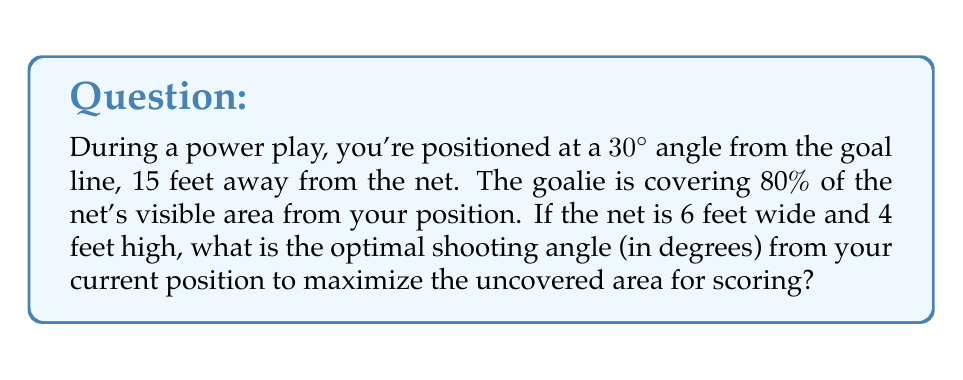Can you solve this math problem? Let's approach this step-by-step:

1) First, we need to calculate the visible area of the net from your position. The net's dimensions are 6 feet wide and 4 feet high, but due to your angle, the visible width will be less.

2) The visible width can be calculated using trigonometry:
   $$\text{Visible Width} = 6 \cdot \cos(30°) = 6 \cdot \frac{\sqrt{3}}{2} = 3\sqrt{3} \approx 5.2 \text{ feet}$$

3) The visible area of the net is thus:
   $$\text{Visible Area} = 5.2 \cdot 4 = 20.8 \text{ sq feet}$$

4) The goalie is covering 80% of this area, leaving 20% uncovered:
   $$\text{Uncovered Area} = 20.8 \cdot 0.2 = 4.16 \text{ sq feet}$$

5) To maximize the uncovered area for scoring, we need to aim for the center of this uncovered area. 

6) The uncovered area can be approximated as a rectangle. If we assume it's evenly distributed around the edges of the net, its center would be at the same spot as the center of the entire visible net area.

7) To find the optimal angle, we need to calculate the angle to the center of the visible net from your position:

   [asy]
   import geometry;
   
   pair A = (0,0);  // Your position
   pair B = (15*cos(30*pi/180), 15*sin(30*pi/180));  // Net center
   
   draw(A--B);
   draw((0,0)--(20,0), arrow=Arrow(TeXHead));
   draw((0,0)--(0,10), arrow=Arrow(TeXHead));
   
   label("You", A, SW);
   label("Net Center", B, NE);
   label("15 ft", (A+B)/2, NW);
   label("$\theta$", (2,0), N);
   
   draw(arc(A,2,0,degrees(B)), arrow=Arrow(TeXHead));
   [/asy]

8) The optimal angle $\theta$ can be calculated using:
   $$\tan(\theta) = \frac{\text{opposite}}{\text{adjacent}} = \frac{15 \cdot \sin(30°)}{15 \cdot \cos(30°)} = \tan(30°)$$

9) Therefore, the optimal shooting angle is the same as your current angle from the goal line, which is 30°.
Answer: 30° 